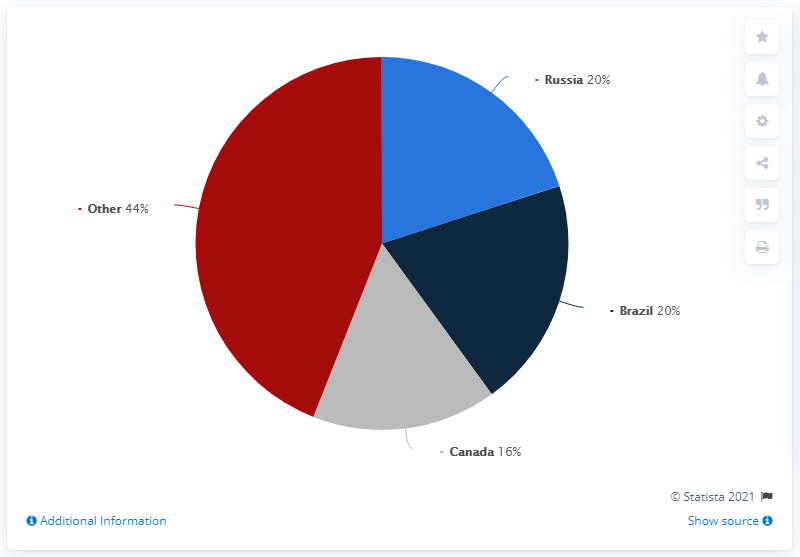Give some essential details in this illustration. Canada is represented by the color gray. In 2020, a significant percentage of US silicon imports came from Russia and Brazil. Specifically, Russia provided approximately 20% of US silicon imports, while Brazil contributed approximately 10%. These figures highlight the importance of these countries as global suppliers of silicon and the potential impact of trade policies on the US silicon market. Brazil is more than Canada by a percentage of 4%. 